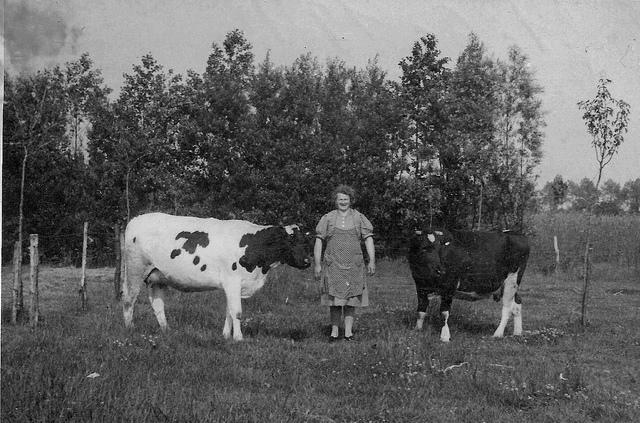Is anyone wearing boots?
Write a very short answer. No. Is this an old image?
Keep it brief. Yes. Is this photo more than 10 years old?
Quick response, please. Yes. Are the cows on a farm?
Quick response, please. Yes. Is there a dog in the photo?
Write a very short answer. No. How many legs are there?
Concise answer only. 10. Are there three cows in the picture?
Write a very short answer. No. What do people get from these animals?
Short answer required. Milk. Are the cows walking in the same direction or opposite from each other?
Quick response, please. Opposite. How many cows are there?
Give a very brief answer. 2. What type of shoe is the lady in the dress wearing?
Give a very brief answer. Boots. Is the woman scared of the cows?
Concise answer only. No. Is one of these animals a baby?
Quick response, please. No. 